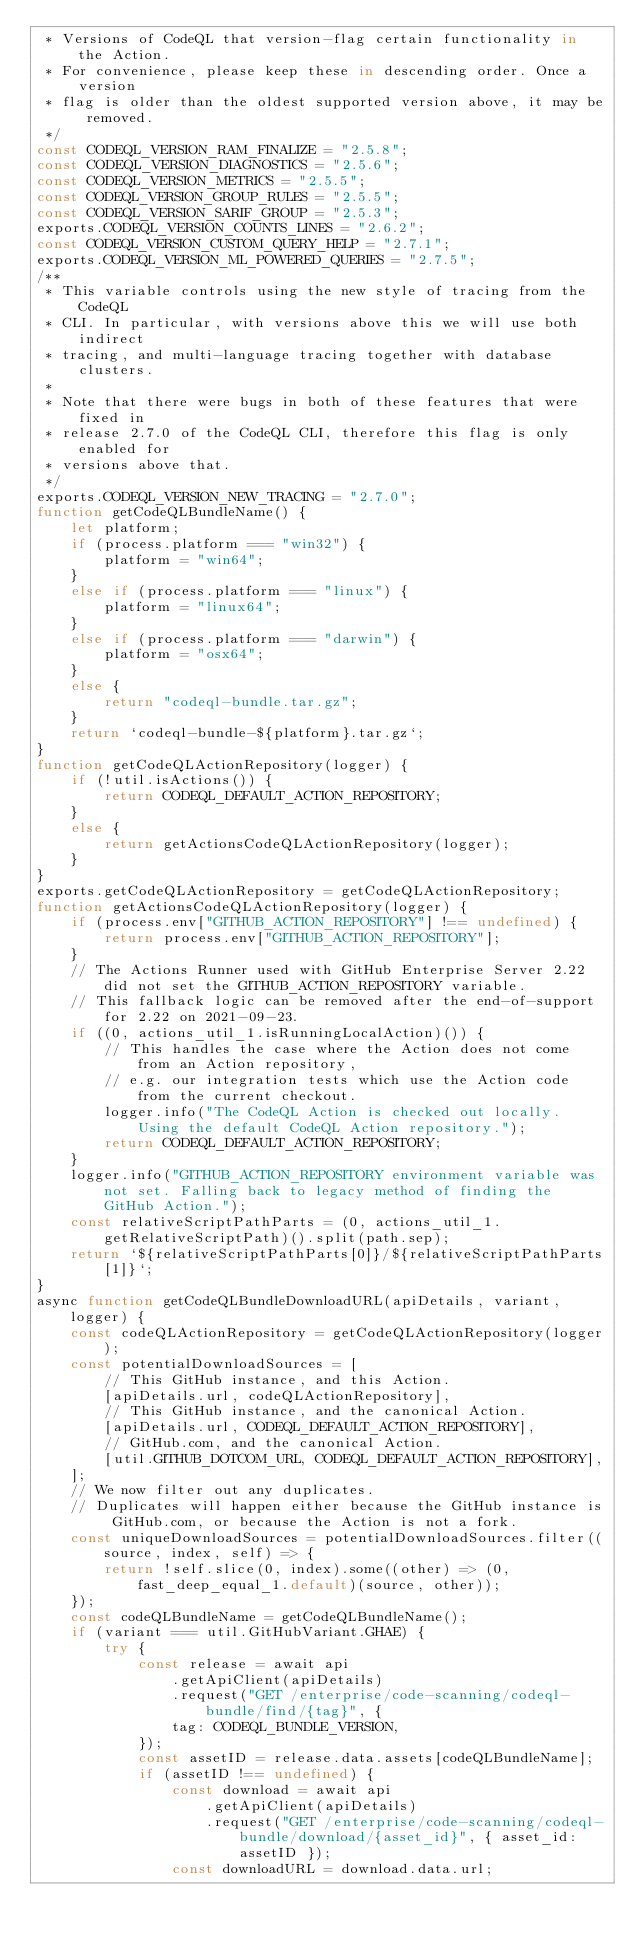Convert code to text. <code><loc_0><loc_0><loc_500><loc_500><_JavaScript_> * Versions of CodeQL that version-flag certain functionality in the Action.
 * For convenience, please keep these in descending order. Once a version
 * flag is older than the oldest supported version above, it may be removed.
 */
const CODEQL_VERSION_RAM_FINALIZE = "2.5.8";
const CODEQL_VERSION_DIAGNOSTICS = "2.5.6";
const CODEQL_VERSION_METRICS = "2.5.5";
const CODEQL_VERSION_GROUP_RULES = "2.5.5";
const CODEQL_VERSION_SARIF_GROUP = "2.5.3";
exports.CODEQL_VERSION_COUNTS_LINES = "2.6.2";
const CODEQL_VERSION_CUSTOM_QUERY_HELP = "2.7.1";
exports.CODEQL_VERSION_ML_POWERED_QUERIES = "2.7.5";
/**
 * This variable controls using the new style of tracing from the CodeQL
 * CLI. In particular, with versions above this we will use both indirect
 * tracing, and multi-language tracing together with database clusters.
 *
 * Note that there were bugs in both of these features that were fixed in
 * release 2.7.0 of the CodeQL CLI, therefore this flag is only enabled for
 * versions above that.
 */
exports.CODEQL_VERSION_NEW_TRACING = "2.7.0";
function getCodeQLBundleName() {
    let platform;
    if (process.platform === "win32") {
        platform = "win64";
    }
    else if (process.platform === "linux") {
        platform = "linux64";
    }
    else if (process.platform === "darwin") {
        platform = "osx64";
    }
    else {
        return "codeql-bundle.tar.gz";
    }
    return `codeql-bundle-${platform}.tar.gz`;
}
function getCodeQLActionRepository(logger) {
    if (!util.isActions()) {
        return CODEQL_DEFAULT_ACTION_REPOSITORY;
    }
    else {
        return getActionsCodeQLActionRepository(logger);
    }
}
exports.getCodeQLActionRepository = getCodeQLActionRepository;
function getActionsCodeQLActionRepository(logger) {
    if (process.env["GITHUB_ACTION_REPOSITORY"] !== undefined) {
        return process.env["GITHUB_ACTION_REPOSITORY"];
    }
    // The Actions Runner used with GitHub Enterprise Server 2.22 did not set the GITHUB_ACTION_REPOSITORY variable.
    // This fallback logic can be removed after the end-of-support for 2.22 on 2021-09-23.
    if ((0, actions_util_1.isRunningLocalAction)()) {
        // This handles the case where the Action does not come from an Action repository,
        // e.g. our integration tests which use the Action code from the current checkout.
        logger.info("The CodeQL Action is checked out locally. Using the default CodeQL Action repository.");
        return CODEQL_DEFAULT_ACTION_REPOSITORY;
    }
    logger.info("GITHUB_ACTION_REPOSITORY environment variable was not set. Falling back to legacy method of finding the GitHub Action.");
    const relativeScriptPathParts = (0, actions_util_1.getRelativeScriptPath)().split(path.sep);
    return `${relativeScriptPathParts[0]}/${relativeScriptPathParts[1]}`;
}
async function getCodeQLBundleDownloadURL(apiDetails, variant, logger) {
    const codeQLActionRepository = getCodeQLActionRepository(logger);
    const potentialDownloadSources = [
        // This GitHub instance, and this Action.
        [apiDetails.url, codeQLActionRepository],
        // This GitHub instance, and the canonical Action.
        [apiDetails.url, CODEQL_DEFAULT_ACTION_REPOSITORY],
        // GitHub.com, and the canonical Action.
        [util.GITHUB_DOTCOM_URL, CODEQL_DEFAULT_ACTION_REPOSITORY],
    ];
    // We now filter out any duplicates.
    // Duplicates will happen either because the GitHub instance is GitHub.com, or because the Action is not a fork.
    const uniqueDownloadSources = potentialDownloadSources.filter((source, index, self) => {
        return !self.slice(0, index).some((other) => (0, fast_deep_equal_1.default)(source, other));
    });
    const codeQLBundleName = getCodeQLBundleName();
    if (variant === util.GitHubVariant.GHAE) {
        try {
            const release = await api
                .getApiClient(apiDetails)
                .request("GET /enterprise/code-scanning/codeql-bundle/find/{tag}", {
                tag: CODEQL_BUNDLE_VERSION,
            });
            const assetID = release.data.assets[codeQLBundleName];
            if (assetID !== undefined) {
                const download = await api
                    .getApiClient(apiDetails)
                    .request("GET /enterprise/code-scanning/codeql-bundle/download/{asset_id}", { asset_id: assetID });
                const downloadURL = download.data.url;</code> 